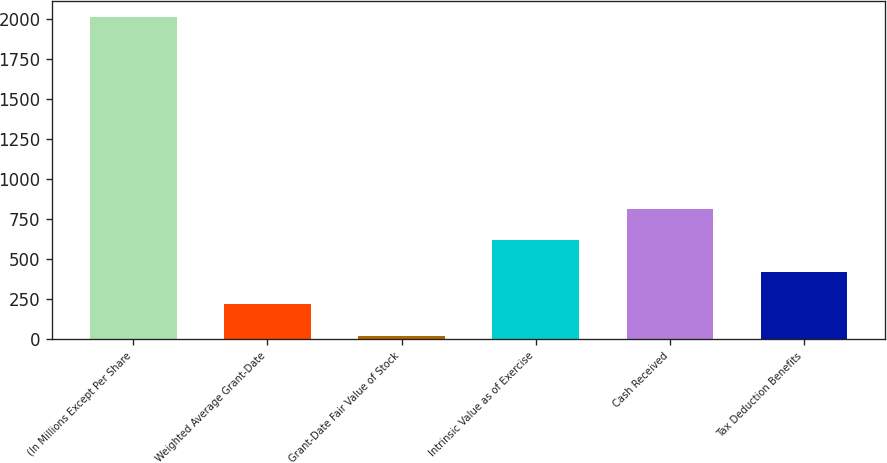<chart> <loc_0><loc_0><loc_500><loc_500><bar_chart><fcel>(In Millions Except Per Share<fcel>Weighted Average Grant-Date<fcel>Grant-Date Fair Value of Stock<fcel>Intrinsic Value as of Exercise<fcel>Cash Received<fcel>Tax Deduction Benefits<nl><fcel>2015<fcel>215.9<fcel>16<fcel>615.7<fcel>815.6<fcel>415.8<nl></chart> 